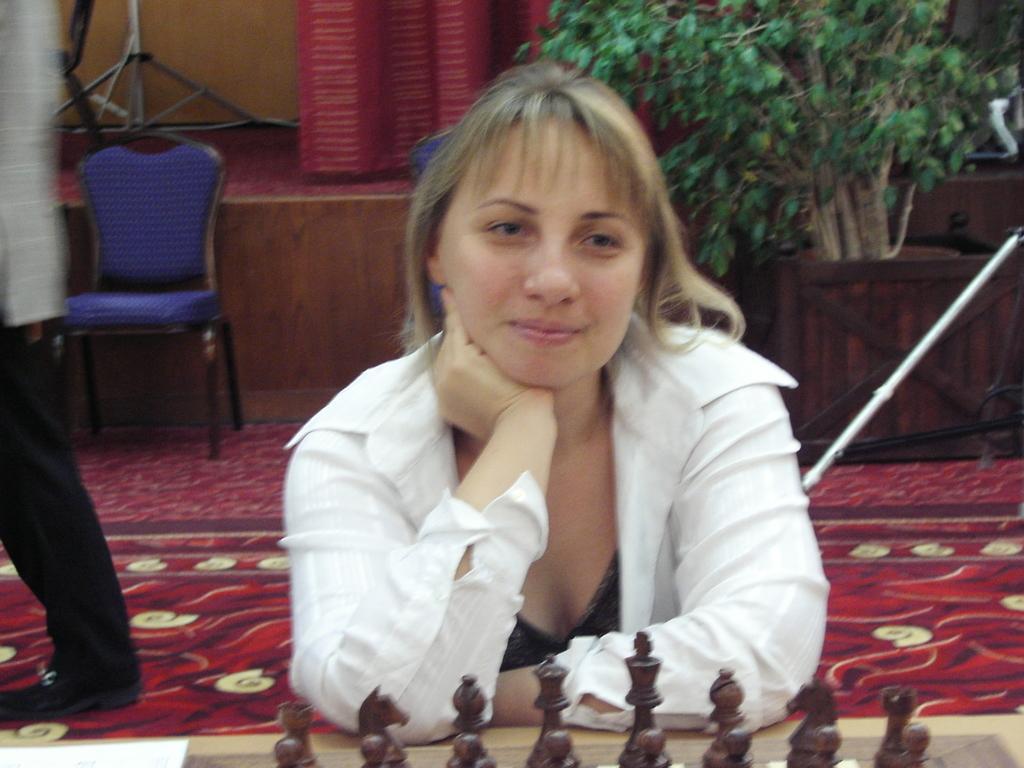Can you describe this image briefly? In this image there is person, chess board, chess coins in the foreground. There is a person , chair in the left corner. There is a potted plant in the right corner. There is wall in the background. And there is a mat at the bottom. 